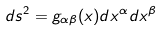<formula> <loc_0><loc_0><loc_500><loc_500>d s ^ { 2 } = g _ { \alpha \beta } ( x ) d x ^ { \alpha } d x ^ { \beta }</formula> 